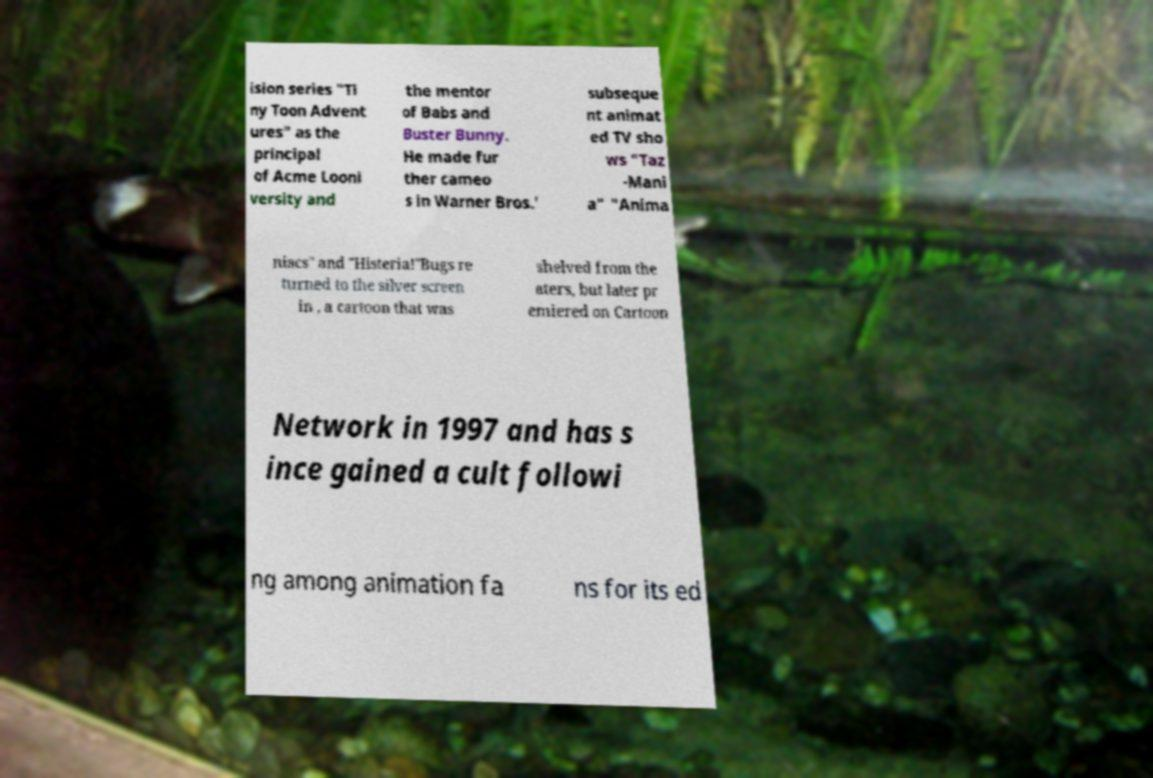I need the written content from this picture converted into text. Can you do that? ision series "Ti ny Toon Advent ures" as the principal of Acme Looni versity and the mentor of Babs and Buster Bunny. He made fur ther cameo s in Warner Bros.' subseque nt animat ed TV sho ws "Taz -Mani a" "Anima niacs" and "Histeria!"Bugs re turned to the silver screen in , a cartoon that was shelved from the aters, but later pr emiered on Cartoon Network in 1997 and has s ince gained a cult followi ng among animation fa ns for its ed 